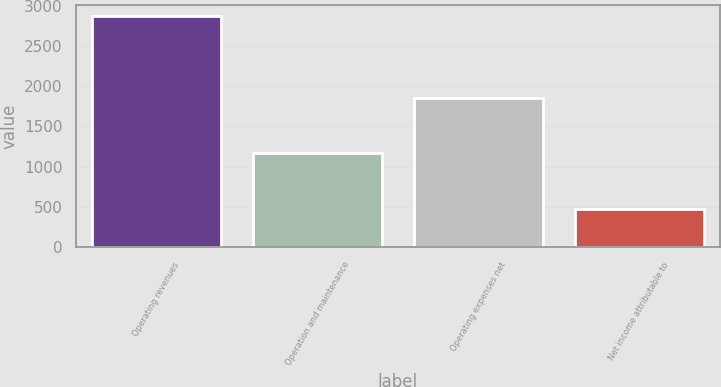Convert chart to OTSL. <chart><loc_0><loc_0><loc_500><loc_500><bar_chart><fcel>Operating revenues<fcel>Operation and maintenance<fcel>Operating expenses net<fcel>Net income attributable to<nl><fcel>2871<fcel>1176<fcel>1852<fcel>472<nl></chart> 